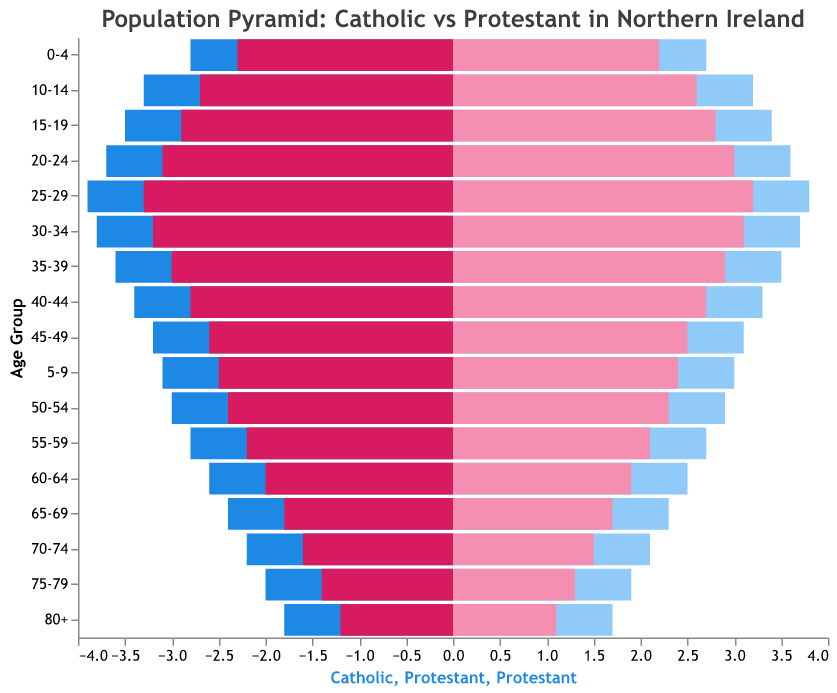Which age group has the largest population for Catholic males? By examining the negative values on the x-axis associated with Catholic males, we identify the bar that extends the furthest left. The largest value for Catholic males is -3.9 in the age group 25-29.
Answer: 25-29 What is the difference in population between Catholic females and Protestant females in the 0-4 age group? For the 0-4 age group, the population of Catholic females is 2.7, and the population of Protestant females is 2.2. The difference is calculated as 2.7 - 2.2.
Answer: 0.5 Which group has the smallest population in the 80+ category? By comparison of the absolute values for the 80+ age group across the four categories, Protestant males have the smallest population at 1.2.
Answer: Protestant males What is the trend in population for Catholic males from age group 0-4 to age group 25-29? Observing the data for Catholic males from age group 0-4 up to 25-29, we see the values increase from -2.8 to -3.9, indicating a growing population as the age increases.
Answer: Increasing How do the populations of Catholic males and Catholic females compare in the 50-54 age group? The population for Catholic males in the 50-54 age group is -3.0, while for Catholic females it is 2.9. Comparing the absolute values, both have nearly the same population but males are slightly higher.
Answer: Nearly equal Which age group has an equal population for Protestant males and females? Looking through each age group, in the 60-64 age group, both Protestant males and females have populations of approximately 2.0 and 1.9 respectively, being very close to equal.
Answer: 60-64 